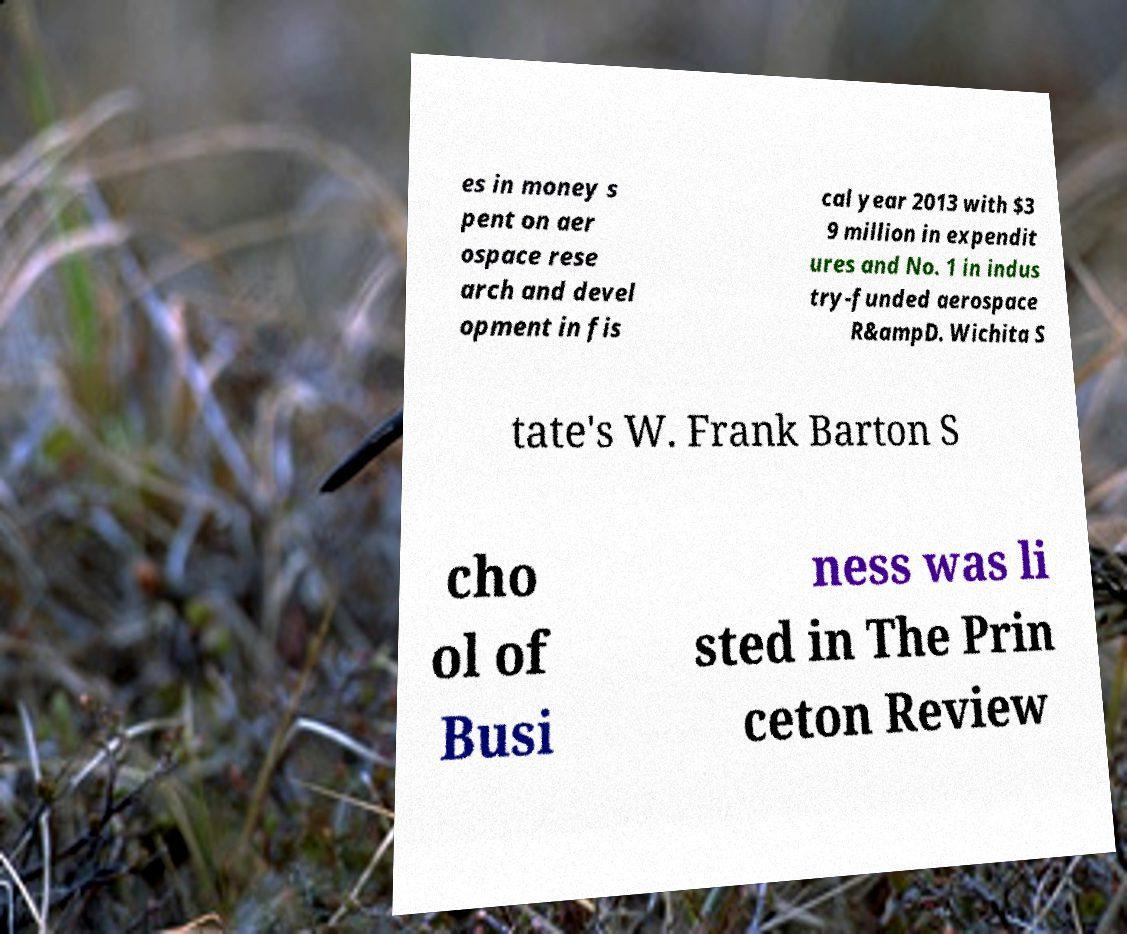Could you extract and type out the text from this image? es in money s pent on aer ospace rese arch and devel opment in fis cal year 2013 with $3 9 million in expendit ures and No. 1 in indus try-funded aerospace R&ampD. Wichita S tate's W. Frank Barton S cho ol of Busi ness was li sted in The Prin ceton Review 